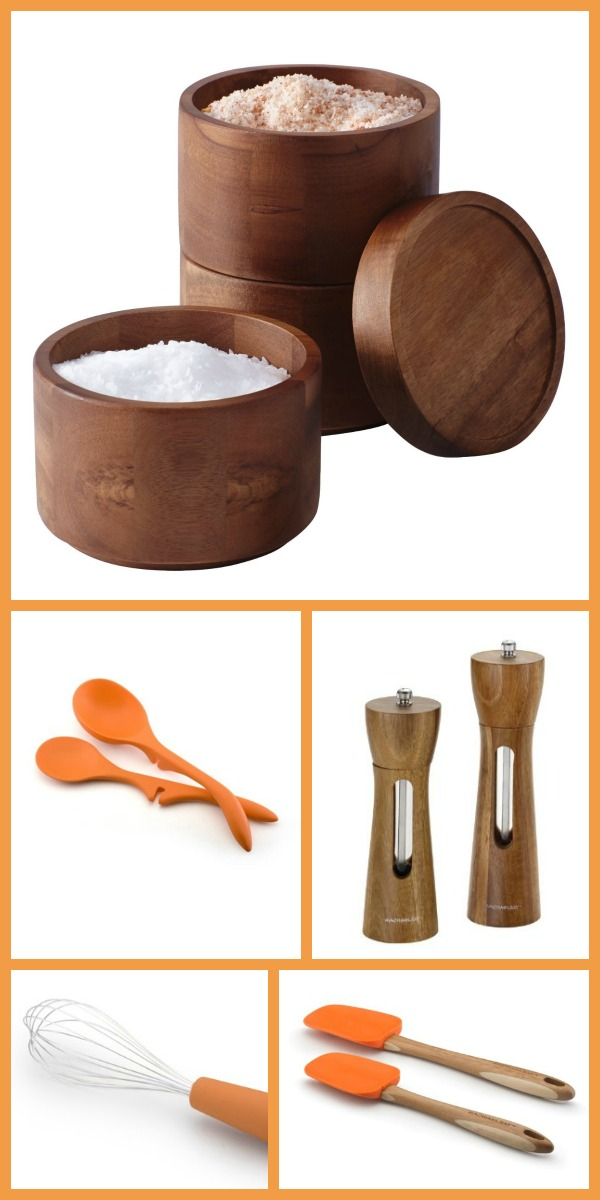What are some practical uses for the wooden containers shown in the image? The wooden containers shown in the image are ideal for storing various kitchen essentials such as salt, sugar, spices, herbs, or even snacks. The natural wood design adds a rustic charm to any kitchen decor while helping to keep ingredients fresh and accessible. 